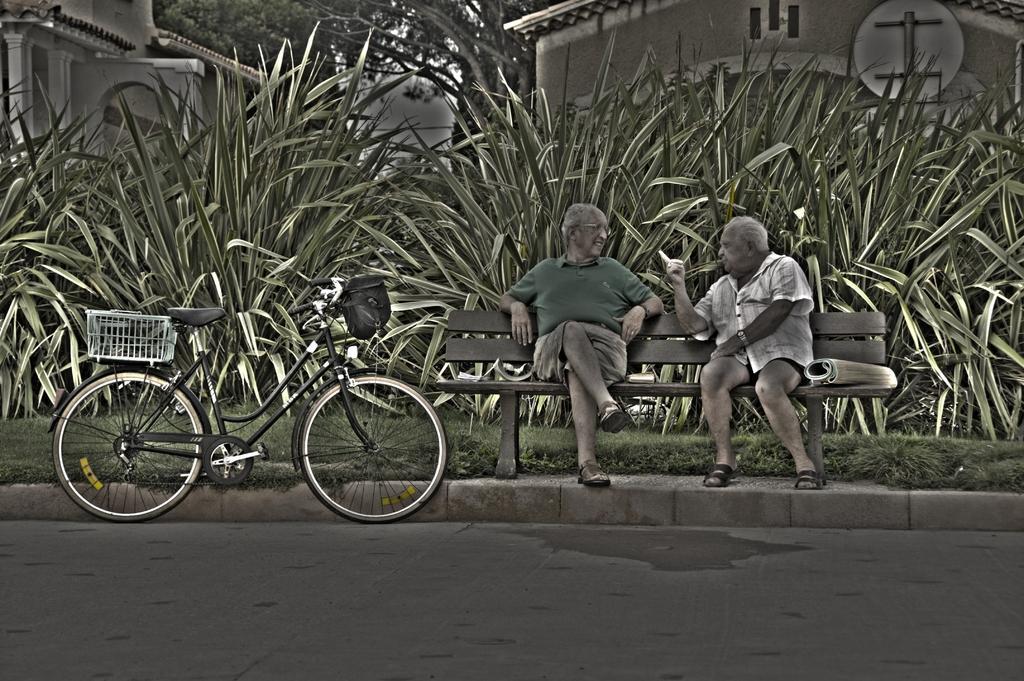Can you describe this image briefly? In this picture we can see a bicycle on the road, and two persons are seated on the bench, in the background we can see couple of plants, trees and buildings. 